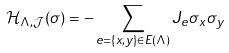<formula> <loc_0><loc_0><loc_500><loc_500>\mathcal { H } _ { \Lambda , \mathcal { J } } ( \sigma ) = - \sum _ { e = \{ x , y \} \in E ( \Lambda ) } J _ { e } \sigma _ { x } \sigma _ { y }</formula> 